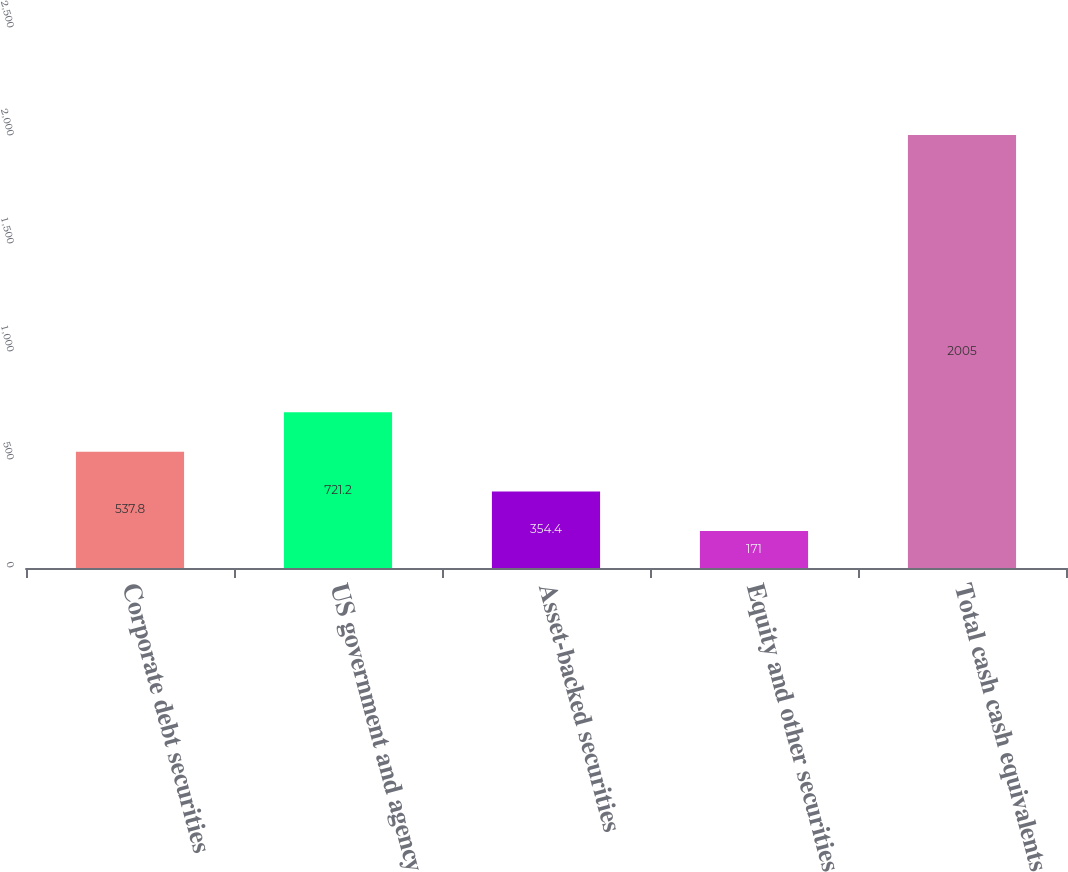Convert chart. <chart><loc_0><loc_0><loc_500><loc_500><bar_chart><fcel>Corporate debt securities<fcel>US government and agency<fcel>Asset-backed securities<fcel>Equity and other securities<fcel>Total cash cash equivalents<nl><fcel>537.8<fcel>721.2<fcel>354.4<fcel>171<fcel>2005<nl></chart> 